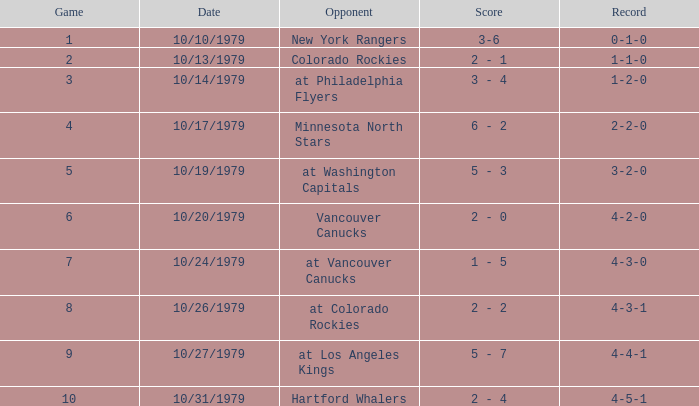What is the score for the opponent Vancouver Canucks? 2 - 0. 